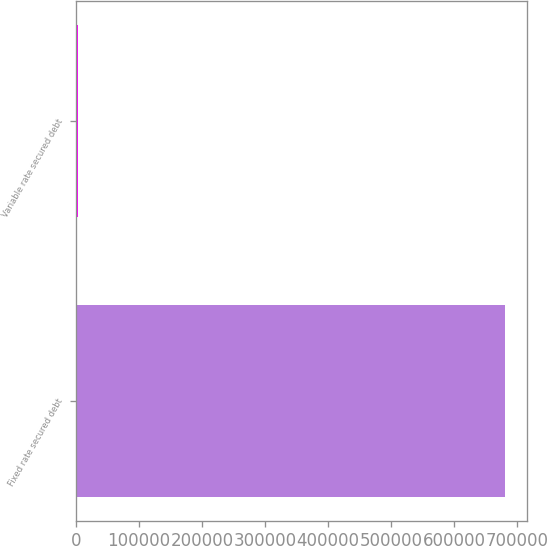Convert chart to OTSL. <chart><loc_0><loc_0><loc_500><loc_500><bar_chart><fcel>Fixed rate secured debt<fcel>Variable rate secured debt<nl><fcel>681122<fcel>3400<nl></chart> 